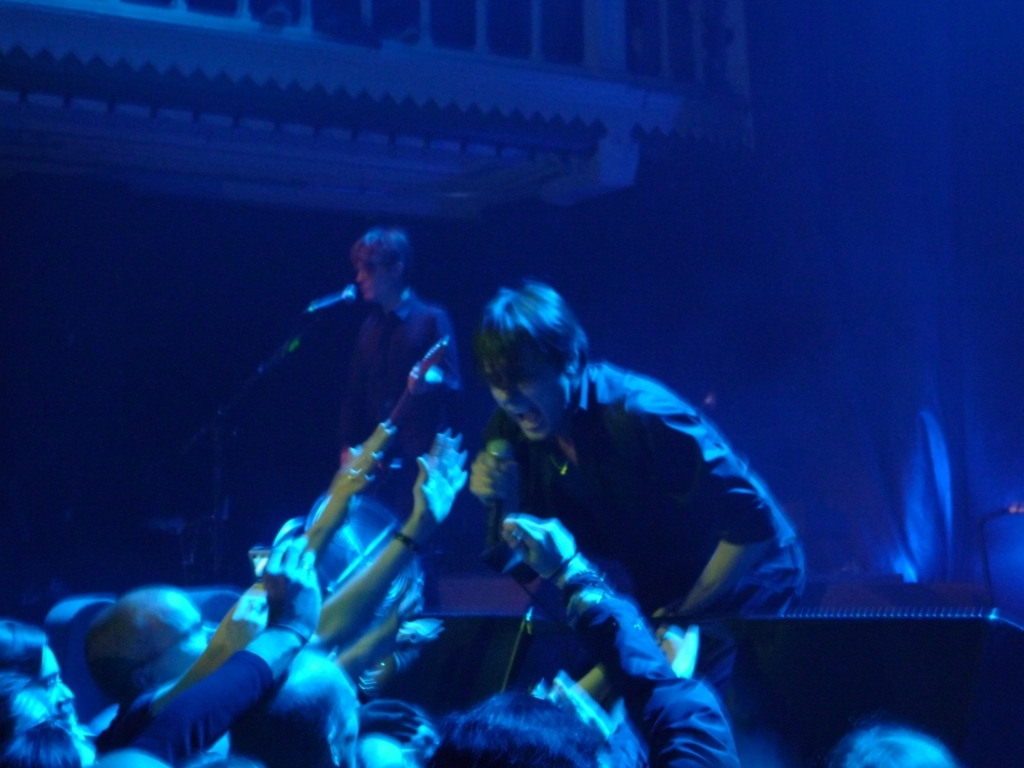Can you describe the atmosphere of the concert shown in this image? The atmosphere in the image appears to be vibrant and energetic, with the artist engaging closely with the audience. The blue-toned stage lighting adds to the intensity of the scene, reflecting a typical concert environment full of excitement and lively interaction. 